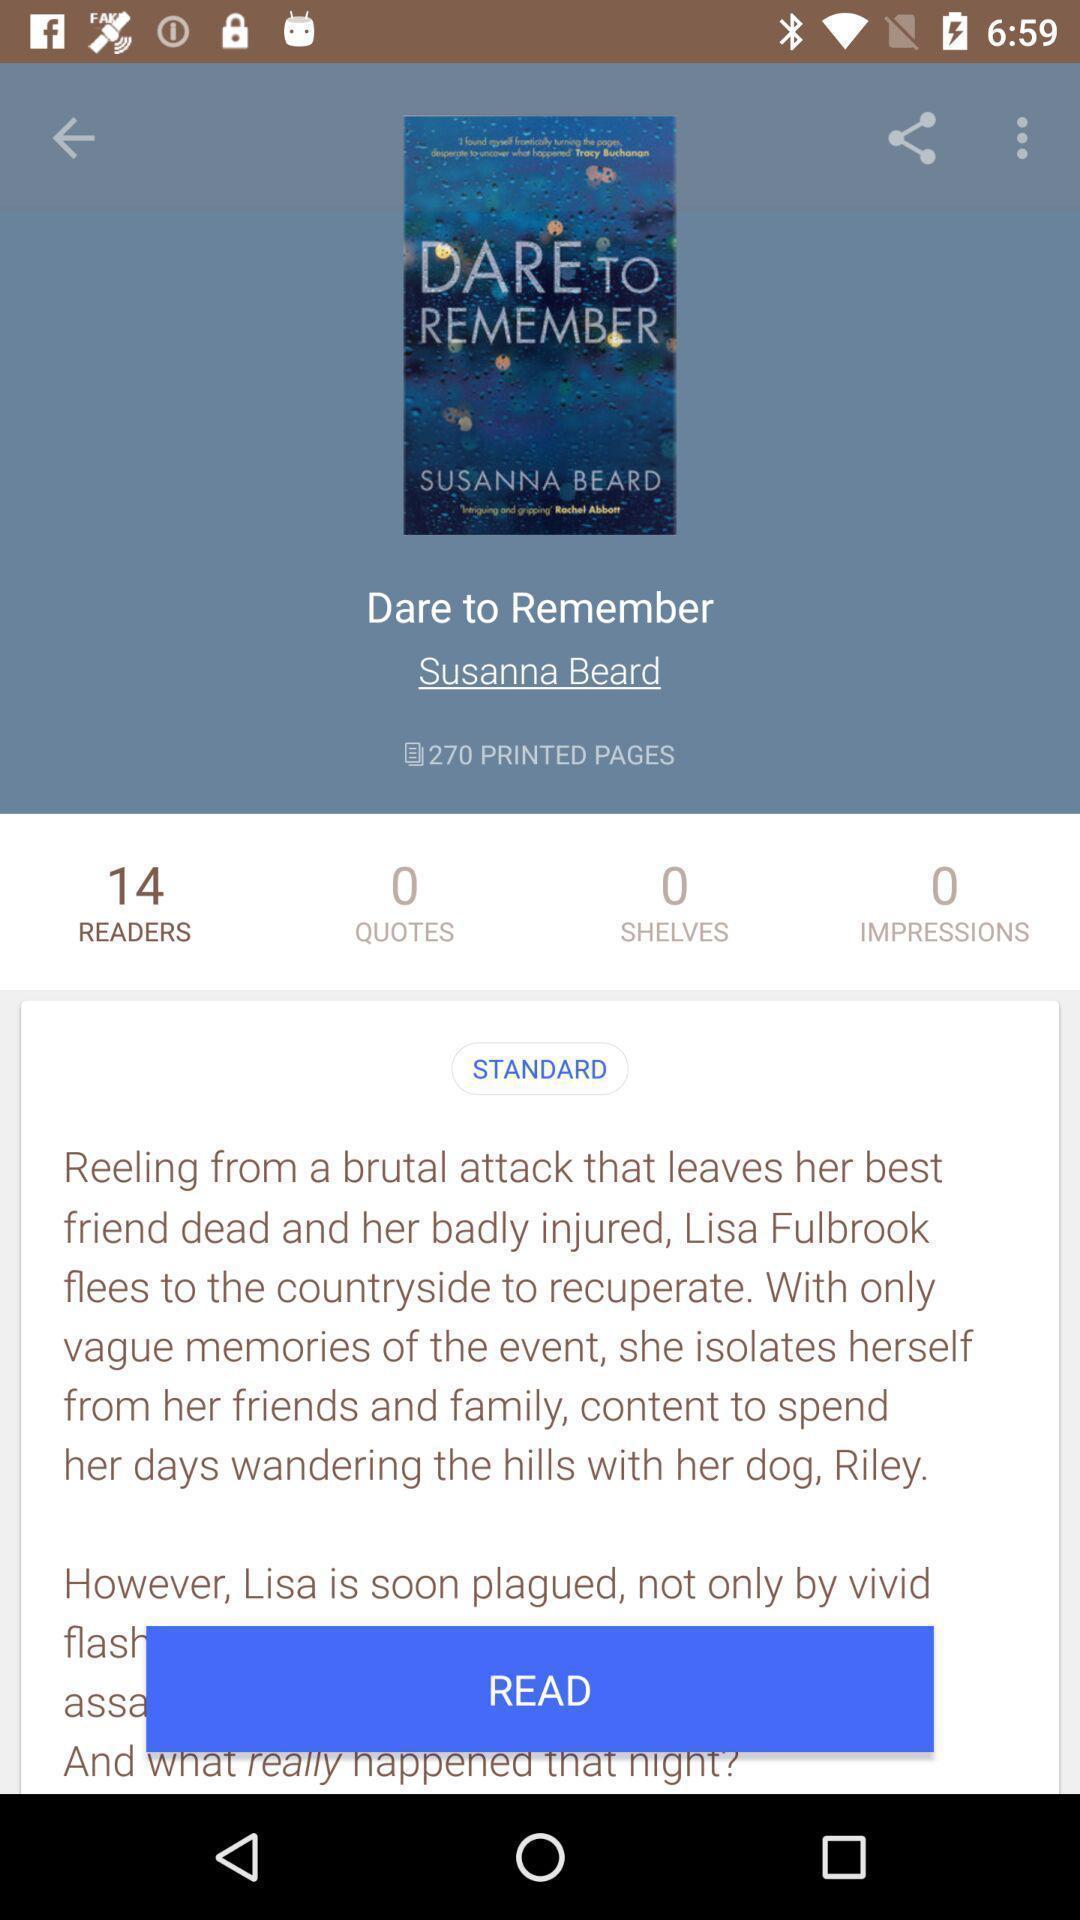Give me a narrative description of this picture. Screen shows an information about a book. 